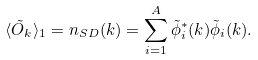<formula> <loc_0><loc_0><loc_500><loc_500>\langle { \tilde { O } } _ { k } \rangle _ { 1 } = n _ { S D } ( { k } ) = \sum _ { i = 1 } ^ { A } \tilde { \phi } _ { i } ^ { * } ( { k } ) \tilde { \phi } _ { i } ( { k } ) .</formula> 